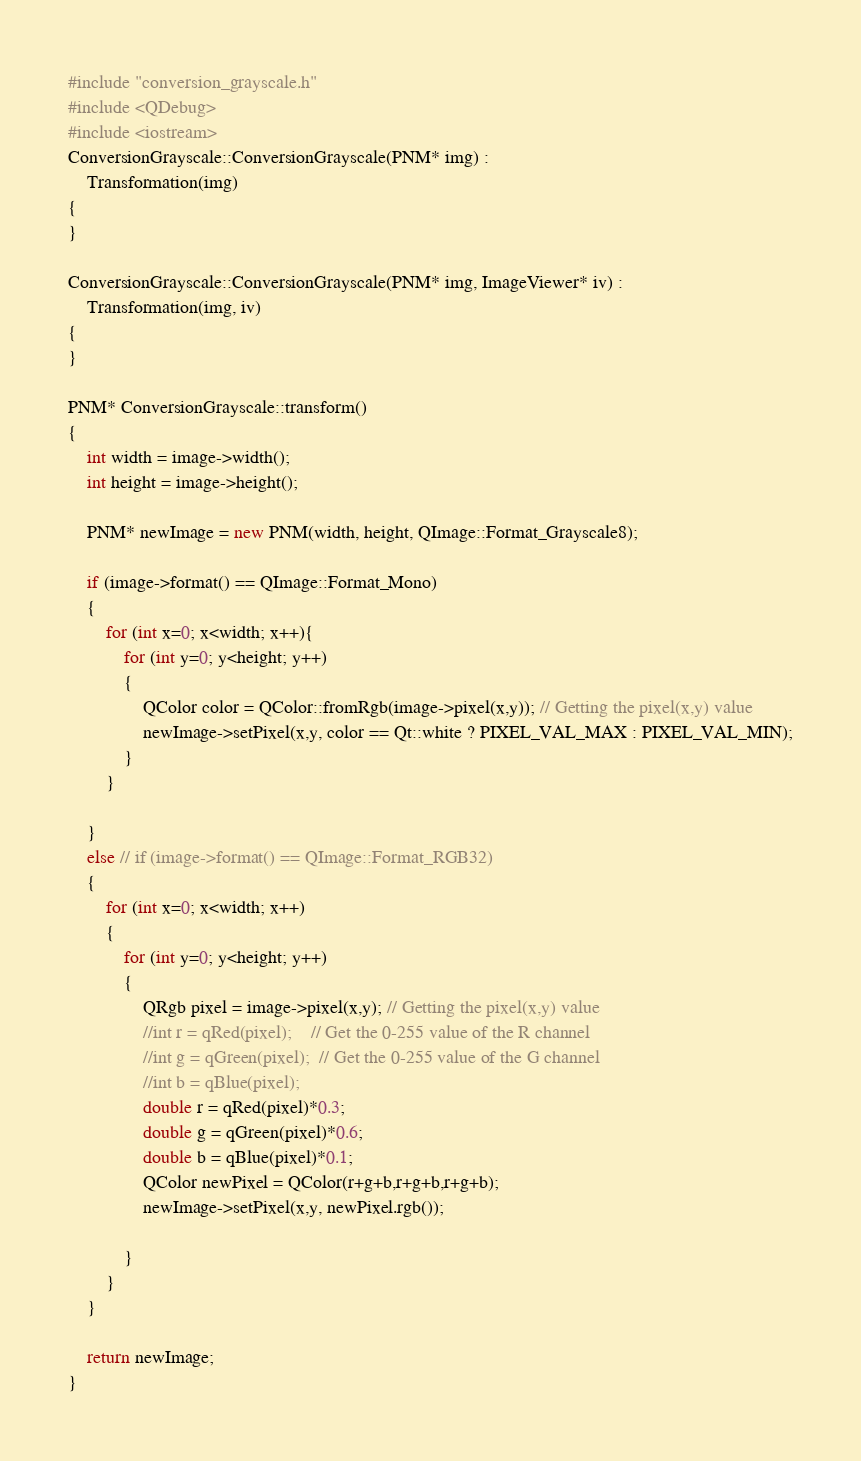Convert code to text. <code><loc_0><loc_0><loc_500><loc_500><_C++_>#include "conversion_grayscale.h"
#include <QDebug>
#include <iostream>
ConversionGrayscale::ConversionGrayscale(PNM* img) :
    Transformation(img)
{
}

ConversionGrayscale::ConversionGrayscale(PNM* img, ImageViewer* iv) :
    Transformation(img, iv)
{
}

PNM* ConversionGrayscale::transform()
{
    int width = image->width();
    int height = image->height();

    PNM* newImage = new PNM(width, height, QImage::Format_Grayscale8);

    if (image->format() == QImage::Format_Mono)
    {
        for (int x=0; x<width; x++){
            for (int y=0; y<height; y++)
            {
                QColor color = QColor::fromRgb(image->pixel(x,y)); // Getting the pixel(x,y) value
                newImage->setPixel(x,y, color == Qt::white ? PIXEL_VAL_MAX : PIXEL_VAL_MIN);
            }
        }

    }
    else // if (image->format() == QImage::Format_RGB32)
    {
        for (int x=0; x<width; x++)
        {
            for (int y=0; y<height; y++)
            {
                QRgb pixel = image->pixel(x,y); // Getting the pixel(x,y) value
                //int r = qRed(pixel);    // Get the 0-255 value of the R channel
                //int g = qGreen(pixel);  // Get the 0-255 value of the G channel
                //int b = qBlue(pixel);
                double r = qRed(pixel)*0.3;
                double g = qGreen(pixel)*0.6;
                double b = qBlue(pixel)*0.1;
                QColor newPixel = QColor(r+g+b,r+g+b,r+g+b);
                newImage->setPixel(x,y, newPixel.rgb());

            }
        }
    }

    return newImage;
}
</code> 